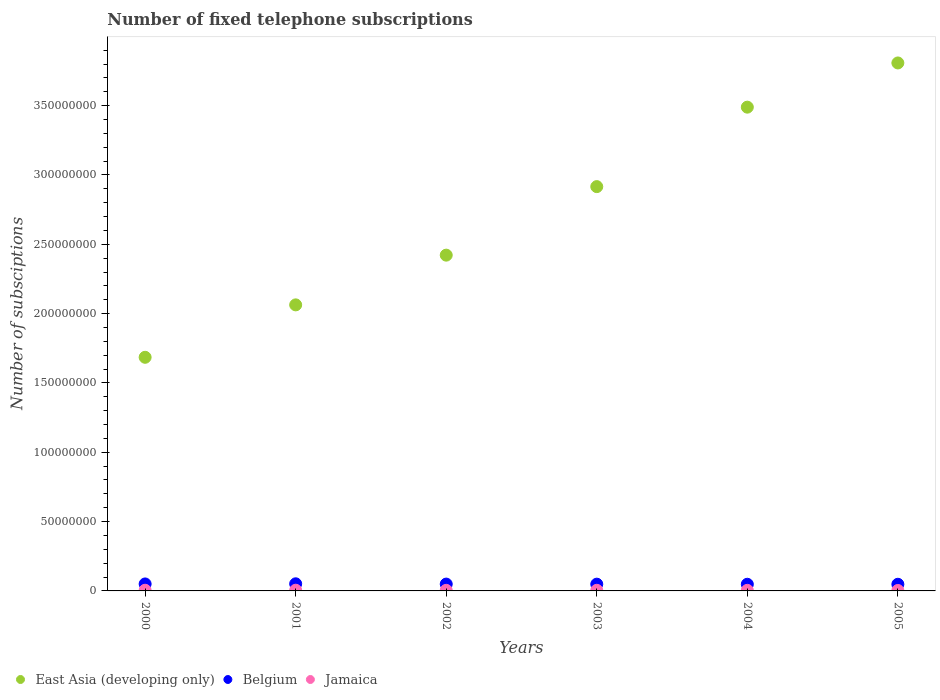Is the number of dotlines equal to the number of legend labels?
Make the answer very short. Yes. What is the number of fixed telephone subscriptions in East Asia (developing only) in 2001?
Provide a short and direct response. 2.06e+08. Across all years, what is the maximum number of fixed telephone subscriptions in Jamaica?
Your response must be concise. 5.11e+05. Across all years, what is the minimum number of fixed telephone subscriptions in Jamaica?
Provide a succinct answer. 3.19e+05. What is the total number of fixed telephone subscriptions in East Asia (developing only) in the graph?
Offer a very short reply. 1.64e+09. What is the difference between the number of fixed telephone subscriptions in Belgium in 2001 and that in 2005?
Offer a very short reply. 3.37e+05. What is the difference between the number of fixed telephone subscriptions in East Asia (developing only) in 2003 and the number of fixed telephone subscriptions in Belgium in 2001?
Provide a succinct answer. 2.86e+08. What is the average number of fixed telephone subscriptions in East Asia (developing only) per year?
Your response must be concise. 2.73e+08. In the year 2002, what is the difference between the number of fixed telephone subscriptions in East Asia (developing only) and number of fixed telephone subscriptions in Belgium?
Provide a succinct answer. 2.37e+08. In how many years, is the number of fixed telephone subscriptions in Belgium greater than 110000000?
Provide a succinct answer. 0. What is the ratio of the number of fixed telephone subscriptions in East Asia (developing only) in 2001 to that in 2005?
Your answer should be compact. 0.54. What is the difference between the highest and the second highest number of fixed telephone subscriptions in Jamaica?
Your response must be concise. 1.78e+04. What is the difference between the highest and the lowest number of fixed telephone subscriptions in Jamaica?
Keep it short and to the point. 1.92e+05. In how many years, is the number of fixed telephone subscriptions in Jamaica greater than the average number of fixed telephone subscriptions in Jamaica taken over all years?
Ensure brevity in your answer.  3. How many dotlines are there?
Give a very brief answer. 3. How many years are there in the graph?
Your response must be concise. 6. Are the values on the major ticks of Y-axis written in scientific E-notation?
Offer a very short reply. No. Does the graph contain grids?
Provide a succinct answer. No. Where does the legend appear in the graph?
Offer a terse response. Bottom left. What is the title of the graph?
Your answer should be very brief. Number of fixed telephone subscriptions. Does "West Bank and Gaza" appear as one of the legend labels in the graph?
Keep it short and to the point. No. What is the label or title of the Y-axis?
Ensure brevity in your answer.  Number of subsciptions. What is the Number of subsciptions of East Asia (developing only) in 2000?
Offer a terse response. 1.68e+08. What is the Number of subsciptions of Belgium in 2000?
Offer a very short reply. 5.04e+06. What is the Number of subsciptions of Jamaica in 2000?
Keep it short and to the point. 4.94e+05. What is the Number of subsciptions in East Asia (developing only) in 2001?
Offer a very short reply. 2.06e+08. What is the Number of subsciptions in Belgium in 2001?
Your answer should be compact. 5.13e+06. What is the Number of subsciptions in Jamaica in 2001?
Your answer should be very brief. 5.11e+05. What is the Number of subsciptions in East Asia (developing only) in 2002?
Offer a very short reply. 2.42e+08. What is the Number of subsciptions of Belgium in 2002?
Give a very brief answer. 4.93e+06. What is the Number of subsciptions in Jamaica in 2002?
Provide a short and direct response. 4.35e+05. What is the Number of subsciptions of East Asia (developing only) in 2003?
Ensure brevity in your answer.  2.92e+08. What is the Number of subsciptions of Belgium in 2003?
Keep it short and to the point. 4.88e+06. What is the Number of subsciptions of Jamaica in 2003?
Your answer should be compact. 4.59e+05. What is the Number of subsciptions in East Asia (developing only) in 2004?
Provide a short and direct response. 3.49e+08. What is the Number of subsciptions in Belgium in 2004?
Your answer should be compact. 4.80e+06. What is the Number of subsciptions of Jamaica in 2004?
Make the answer very short. 4.23e+05. What is the Number of subsciptions of East Asia (developing only) in 2005?
Offer a very short reply. 3.81e+08. What is the Number of subsciptions in Belgium in 2005?
Offer a terse response. 4.79e+06. What is the Number of subsciptions of Jamaica in 2005?
Your answer should be very brief. 3.19e+05. Across all years, what is the maximum Number of subsciptions of East Asia (developing only)?
Provide a short and direct response. 3.81e+08. Across all years, what is the maximum Number of subsciptions of Belgium?
Your answer should be compact. 5.13e+06. Across all years, what is the maximum Number of subsciptions of Jamaica?
Ensure brevity in your answer.  5.11e+05. Across all years, what is the minimum Number of subsciptions in East Asia (developing only)?
Your response must be concise. 1.68e+08. Across all years, what is the minimum Number of subsciptions of Belgium?
Your response must be concise. 4.79e+06. Across all years, what is the minimum Number of subsciptions in Jamaica?
Your answer should be very brief. 3.19e+05. What is the total Number of subsciptions of East Asia (developing only) in the graph?
Give a very brief answer. 1.64e+09. What is the total Number of subsciptions of Belgium in the graph?
Your answer should be compact. 2.96e+07. What is the total Number of subsciptions of Jamaica in the graph?
Your answer should be very brief. 2.64e+06. What is the difference between the Number of subsciptions of East Asia (developing only) in 2000 and that in 2001?
Offer a terse response. -3.78e+07. What is the difference between the Number of subsciptions in Belgium in 2000 and that in 2001?
Provide a short and direct response. -9.53e+04. What is the difference between the Number of subsciptions in Jamaica in 2000 and that in 2001?
Offer a very short reply. -1.78e+04. What is the difference between the Number of subsciptions in East Asia (developing only) in 2000 and that in 2002?
Your answer should be compact. -7.37e+07. What is the difference between the Number of subsciptions in Belgium in 2000 and that in 2002?
Make the answer very short. 1.05e+05. What is the difference between the Number of subsciptions of Jamaica in 2000 and that in 2002?
Your response must be concise. 5.88e+04. What is the difference between the Number of subsciptions of East Asia (developing only) in 2000 and that in 2003?
Your response must be concise. -1.23e+08. What is the difference between the Number of subsciptions of Belgium in 2000 and that in 2003?
Your answer should be compact. 1.61e+05. What is the difference between the Number of subsciptions of Jamaica in 2000 and that in 2003?
Provide a succinct answer. 3.48e+04. What is the difference between the Number of subsciptions in East Asia (developing only) in 2000 and that in 2004?
Keep it short and to the point. -1.80e+08. What is the difference between the Number of subsciptions in Belgium in 2000 and that in 2004?
Ensure brevity in your answer.  2.35e+05. What is the difference between the Number of subsciptions in Jamaica in 2000 and that in 2004?
Your answer should be compact. 7.05e+04. What is the difference between the Number of subsciptions in East Asia (developing only) in 2000 and that in 2005?
Offer a very short reply. -2.12e+08. What is the difference between the Number of subsciptions of Belgium in 2000 and that in 2005?
Ensure brevity in your answer.  2.42e+05. What is the difference between the Number of subsciptions in Jamaica in 2000 and that in 2005?
Your answer should be very brief. 1.75e+05. What is the difference between the Number of subsciptions of East Asia (developing only) in 2001 and that in 2002?
Your answer should be very brief. -3.59e+07. What is the difference between the Number of subsciptions in Belgium in 2001 and that in 2002?
Give a very brief answer. 2.00e+05. What is the difference between the Number of subsciptions of Jamaica in 2001 and that in 2002?
Make the answer very short. 7.65e+04. What is the difference between the Number of subsciptions of East Asia (developing only) in 2001 and that in 2003?
Your answer should be very brief. -8.53e+07. What is the difference between the Number of subsciptions in Belgium in 2001 and that in 2003?
Your answer should be compact. 2.57e+05. What is the difference between the Number of subsciptions in Jamaica in 2001 and that in 2003?
Provide a succinct answer. 5.26e+04. What is the difference between the Number of subsciptions of East Asia (developing only) in 2001 and that in 2004?
Give a very brief answer. -1.43e+08. What is the difference between the Number of subsciptions of Belgium in 2001 and that in 2004?
Your response must be concise. 3.31e+05. What is the difference between the Number of subsciptions of Jamaica in 2001 and that in 2004?
Your answer should be compact. 8.83e+04. What is the difference between the Number of subsciptions of East Asia (developing only) in 2001 and that in 2005?
Your answer should be compact. -1.74e+08. What is the difference between the Number of subsciptions in Belgium in 2001 and that in 2005?
Your answer should be compact. 3.37e+05. What is the difference between the Number of subsciptions in Jamaica in 2001 and that in 2005?
Make the answer very short. 1.92e+05. What is the difference between the Number of subsciptions in East Asia (developing only) in 2002 and that in 2003?
Give a very brief answer. -4.94e+07. What is the difference between the Number of subsciptions in Belgium in 2002 and that in 2003?
Ensure brevity in your answer.  5.66e+04. What is the difference between the Number of subsciptions of Jamaica in 2002 and that in 2003?
Keep it short and to the point. -2.39e+04. What is the difference between the Number of subsciptions in East Asia (developing only) in 2002 and that in 2004?
Offer a very short reply. -1.07e+08. What is the difference between the Number of subsciptions of Belgium in 2002 and that in 2004?
Your response must be concise. 1.31e+05. What is the difference between the Number of subsciptions of Jamaica in 2002 and that in 2004?
Provide a succinct answer. 1.18e+04. What is the difference between the Number of subsciptions in East Asia (developing only) in 2002 and that in 2005?
Provide a short and direct response. -1.39e+08. What is the difference between the Number of subsciptions of Belgium in 2002 and that in 2005?
Ensure brevity in your answer.  1.37e+05. What is the difference between the Number of subsciptions in Jamaica in 2002 and that in 2005?
Offer a very short reply. 1.16e+05. What is the difference between the Number of subsciptions in East Asia (developing only) in 2003 and that in 2004?
Your answer should be very brief. -5.73e+07. What is the difference between the Number of subsciptions of Belgium in 2003 and that in 2004?
Offer a terse response. 7.40e+04. What is the difference between the Number of subsciptions of Jamaica in 2003 and that in 2004?
Your answer should be compact. 3.57e+04. What is the difference between the Number of subsciptions in East Asia (developing only) in 2003 and that in 2005?
Make the answer very short. -8.92e+07. What is the difference between the Number of subsciptions in Belgium in 2003 and that in 2005?
Offer a terse response. 8.04e+04. What is the difference between the Number of subsciptions of Jamaica in 2003 and that in 2005?
Offer a terse response. 1.40e+05. What is the difference between the Number of subsciptions of East Asia (developing only) in 2004 and that in 2005?
Provide a succinct answer. -3.19e+07. What is the difference between the Number of subsciptions of Belgium in 2004 and that in 2005?
Ensure brevity in your answer.  6417. What is the difference between the Number of subsciptions of Jamaica in 2004 and that in 2005?
Provide a succinct answer. 1.04e+05. What is the difference between the Number of subsciptions of East Asia (developing only) in 2000 and the Number of subsciptions of Belgium in 2001?
Ensure brevity in your answer.  1.63e+08. What is the difference between the Number of subsciptions in East Asia (developing only) in 2000 and the Number of subsciptions in Jamaica in 2001?
Give a very brief answer. 1.68e+08. What is the difference between the Number of subsciptions of Belgium in 2000 and the Number of subsciptions of Jamaica in 2001?
Ensure brevity in your answer.  4.53e+06. What is the difference between the Number of subsciptions of East Asia (developing only) in 2000 and the Number of subsciptions of Belgium in 2002?
Your response must be concise. 1.64e+08. What is the difference between the Number of subsciptions in East Asia (developing only) in 2000 and the Number of subsciptions in Jamaica in 2002?
Give a very brief answer. 1.68e+08. What is the difference between the Number of subsciptions in Belgium in 2000 and the Number of subsciptions in Jamaica in 2002?
Provide a succinct answer. 4.60e+06. What is the difference between the Number of subsciptions of East Asia (developing only) in 2000 and the Number of subsciptions of Belgium in 2003?
Provide a short and direct response. 1.64e+08. What is the difference between the Number of subsciptions in East Asia (developing only) in 2000 and the Number of subsciptions in Jamaica in 2003?
Offer a very short reply. 1.68e+08. What is the difference between the Number of subsciptions in Belgium in 2000 and the Number of subsciptions in Jamaica in 2003?
Give a very brief answer. 4.58e+06. What is the difference between the Number of subsciptions in East Asia (developing only) in 2000 and the Number of subsciptions in Belgium in 2004?
Offer a very short reply. 1.64e+08. What is the difference between the Number of subsciptions in East Asia (developing only) in 2000 and the Number of subsciptions in Jamaica in 2004?
Ensure brevity in your answer.  1.68e+08. What is the difference between the Number of subsciptions of Belgium in 2000 and the Number of subsciptions of Jamaica in 2004?
Give a very brief answer. 4.61e+06. What is the difference between the Number of subsciptions in East Asia (developing only) in 2000 and the Number of subsciptions in Belgium in 2005?
Ensure brevity in your answer.  1.64e+08. What is the difference between the Number of subsciptions of East Asia (developing only) in 2000 and the Number of subsciptions of Jamaica in 2005?
Give a very brief answer. 1.68e+08. What is the difference between the Number of subsciptions of Belgium in 2000 and the Number of subsciptions of Jamaica in 2005?
Provide a short and direct response. 4.72e+06. What is the difference between the Number of subsciptions of East Asia (developing only) in 2001 and the Number of subsciptions of Belgium in 2002?
Your answer should be compact. 2.01e+08. What is the difference between the Number of subsciptions in East Asia (developing only) in 2001 and the Number of subsciptions in Jamaica in 2002?
Make the answer very short. 2.06e+08. What is the difference between the Number of subsciptions of Belgium in 2001 and the Number of subsciptions of Jamaica in 2002?
Give a very brief answer. 4.70e+06. What is the difference between the Number of subsciptions of East Asia (developing only) in 2001 and the Number of subsciptions of Belgium in 2003?
Provide a short and direct response. 2.01e+08. What is the difference between the Number of subsciptions of East Asia (developing only) in 2001 and the Number of subsciptions of Jamaica in 2003?
Your answer should be compact. 2.06e+08. What is the difference between the Number of subsciptions in Belgium in 2001 and the Number of subsciptions in Jamaica in 2003?
Your answer should be compact. 4.67e+06. What is the difference between the Number of subsciptions in East Asia (developing only) in 2001 and the Number of subsciptions in Belgium in 2004?
Your response must be concise. 2.01e+08. What is the difference between the Number of subsciptions in East Asia (developing only) in 2001 and the Number of subsciptions in Jamaica in 2004?
Give a very brief answer. 2.06e+08. What is the difference between the Number of subsciptions in Belgium in 2001 and the Number of subsciptions in Jamaica in 2004?
Ensure brevity in your answer.  4.71e+06. What is the difference between the Number of subsciptions of East Asia (developing only) in 2001 and the Number of subsciptions of Belgium in 2005?
Provide a succinct answer. 2.02e+08. What is the difference between the Number of subsciptions in East Asia (developing only) in 2001 and the Number of subsciptions in Jamaica in 2005?
Your response must be concise. 2.06e+08. What is the difference between the Number of subsciptions of Belgium in 2001 and the Number of subsciptions of Jamaica in 2005?
Provide a succinct answer. 4.81e+06. What is the difference between the Number of subsciptions in East Asia (developing only) in 2002 and the Number of subsciptions in Belgium in 2003?
Make the answer very short. 2.37e+08. What is the difference between the Number of subsciptions of East Asia (developing only) in 2002 and the Number of subsciptions of Jamaica in 2003?
Make the answer very short. 2.42e+08. What is the difference between the Number of subsciptions in Belgium in 2002 and the Number of subsciptions in Jamaica in 2003?
Make the answer very short. 4.47e+06. What is the difference between the Number of subsciptions in East Asia (developing only) in 2002 and the Number of subsciptions in Belgium in 2004?
Give a very brief answer. 2.37e+08. What is the difference between the Number of subsciptions in East Asia (developing only) in 2002 and the Number of subsciptions in Jamaica in 2004?
Provide a short and direct response. 2.42e+08. What is the difference between the Number of subsciptions of Belgium in 2002 and the Number of subsciptions of Jamaica in 2004?
Offer a very short reply. 4.51e+06. What is the difference between the Number of subsciptions of East Asia (developing only) in 2002 and the Number of subsciptions of Belgium in 2005?
Offer a terse response. 2.37e+08. What is the difference between the Number of subsciptions in East Asia (developing only) in 2002 and the Number of subsciptions in Jamaica in 2005?
Offer a terse response. 2.42e+08. What is the difference between the Number of subsciptions in Belgium in 2002 and the Number of subsciptions in Jamaica in 2005?
Provide a succinct answer. 4.61e+06. What is the difference between the Number of subsciptions in East Asia (developing only) in 2003 and the Number of subsciptions in Belgium in 2004?
Your response must be concise. 2.87e+08. What is the difference between the Number of subsciptions in East Asia (developing only) in 2003 and the Number of subsciptions in Jamaica in 2004?
Your answer should be very brief. 2.91e+08. What is the difference between the Number of subsciptions of Belgium in 2003 and the Number of subsciptions of Jamaica in 2004?
Your answer should be very brief. 4.45e+06. What is the difference between the Number of subsciptions in East Asia (developing only) in 2003 and the Number of subsciptions in Belgium in 2005?
Give a very brief answer. 2.87e+08. What is the difference between the Number of subsciptions of East Asia (developing only) in 2003 and the Number of subsciptions of Jamaica in 2005?
Provide a succinct answer. 2.91e+08. What is the difference between the Number of subsciptions in Belgium in 2003 and the Number of subsciptions in Jamaica in 2005?
Keep it short and to the point. 4.56e+06. What is the difference between the Number of subsciptions in East Asia (developing only) in 2004 and the Number of subsciptions in Belgium in 2005?
Give a very brief answer. 3.44e+08. What is the difference between the Number of subsciptions of East Asia (developing only) in 2004 and the Number of subsciptions of Jamaica in 2005?
Keep it short and to the point. 3.49e+08. What is the difference between the Number of subsciptions of Belgium in 2004 and the Number of subsciptions of Jamaica in 2005?
Your response must be concise. 4.48e+06. What is the average Number of subsciptions of East Asia (developing only) per year?
Your answer should be compact. 2.73e+08. What is the average Number of subsciptions of Belgium per year?
Offer a terse response. 4.93e+06. What is the average Number of subsciptions of Jamaica per year?
Provide a short and direct response. 4.40e+05. In the year 2000, what is the difference between the Number of subsciptions in East Asia (developing only) and Number of subsciptions in Belgium?
Provide a succinct answer. 1.63e+08. In the year 2000, what is the difference between the Number of subsciptions of East Asia (developing only) and Number of subsciptions of Jamaica?
Provide a succinct answer. 1.68e+08. In the year 2000, what is the difference between the Number of subsciptions in Belgium and Number of subsciptions in Jamaica?
Give a very brief answer. 4.54e+06. In the year 2001, what is the difference between the Number of subsciptions in East Asia (developing only) and Number of subsciptions in Belgium?
Provide a short and direct response. 2.01e+08. In the year 2001, what is the difference between the Number of subsciptions of East Asia (developing only) and Number of subsciptions of Jamaica?
Keep it short and to the point. 2.06e+08. In the year 2001, what is the difference between the Number of subsciptions in Belgium and Number of subsciptions in Jamaica?
Offer a very short reply. 4.62e+06. In the year 2002, what is the difference between the Number of subsciptions in East Asia (developing only) and Number of subsciptions in Belgium?
Give a very brief answer. 2.37e+08. In the year 2002, what is the difference between the Number of subsciptions in East Asia (developing only) and Number of subsciptions in Jamaica?
Make the answer very short. 2.42e+08. In the year 2002, what is the difference between the Number of subsciptions of Belgium and Number of subsciptions of Jamaica?
Provide a short and direct response. 4.50e+06. In the year 2003, what is the difference between the Number of subsciptions of East Asia (developing only) and Number of subsciptions of Belgium?
Provide a short and direct response. 2.87e+08. In the year 2003, what is the difference between the Number of subsciptions of East Asia (developing only) and Number of subsciptions of Jamaica?
Keep it short and to the point. 2.91e+08. In the year 2003, what is the difference between the Number of subsciptions in Belgium and Number of subsciptions in Jamaica?
Your answer should be very brief. 4.42e+06. In the year 2004, what is the difference between the Number of subsciptions in East Asia (developing only) and Number of subsciptions in Belgium?
Ensure brevity in your answer.  3.44e+08. In the year 2004, what is the difference between the Number of subsciptions in East Asia (developing only) and Number of subsciptions in Jamaica?
Your answer should be very brief. 3.48e+08. In the year 2004, what is the difference between the Number of subsciptions in Belgium and Number of subsciptions in Jamaica?
Give a very brief answer. 4.38e+06. In the year 2005, what is the difference between the Number of subsciptions of East Asia (developing only) and Number of subsciptions of Belgium?
Provide a succinct answer. 3.76e+08. In the year 2005, what is the difference between the Number of subsciptions in East Asia (developing only) and Number of subsciptions in Jamaica?
Your answer should be very brief. 3.80e+08. In the year 2005, what is the difference between the Number of subsciptions in Belgium and Number of subsciptions in Jamaica?
Give a very brief answer. 4.48e+06. What is the ratio of the Number of subsciptions in East Asia (developing only) in 2000 to that in 2001?
Offer a very short reply. 0.82. What is the ratio of the Number of subsciptions in Belgium in 2000 to that in 2001?
Your response must be concise. 0.98. What is the ratio of the Number of subsciptions in Jamaica in 2000 to that in 2001?
Provide a short and direct response. 0.97. What is the ratio of the Number of subsciptions in East Asia (developing only) in 2000 to that in 2002?
Your response must be concise. 0.7. What is the ratio of the Number of subsciptions of Belgium in 2000 to that in 2002?
Keep it short and to the point. 1.02. What is the ratio of the Number of subsciptions in Jamaica in 2000 to that in 2002?
Give a very brief answer. 1.14. What is the ratio of the Number of subsciptions in East Asia (developing only) in 2000 to that in 2003?
Your answer should be compact. 0.58. What is the ratio of the Number of subsciptions in Belgium in 2000 to that in 2003?
Provide a short and direct response. 1.03. What is the ratio of the Number of subsciptions of Jamaica in 2000 to that in 2003?
Make the answer very short. 1.08. What is the ratio of the Number of subsciptions in East Asia (developing only) in 2000 to that in 2004?
Keep it short and to the point. 0.48. What is the ratio of the Number of subsciptions of Belgium in 2000 to that in 2004?
Ensure brevity in your answer.  1.05. What is the ratio of the Number of subsciptions in East Asia (developing only) in 2000 to that in 2005?
Offer a very short reply. 0.44. What is the ratio of the Number of subsciptions of Belgium in 2000 to that in 2005?
Provide a succinct answer. 1.05. What is the ratio of the Number of subsciptions in Jamaica in 2000 to that in 2005?
Your answer should be compact. 1.55. What is the ratio of the Number of subsciptions in East Asia (developing only) in 2001 to that in 2002?
Offer a terse response. 0.85. What is the ratio of the Number of subsciptions in Belgium in 2001 to that in 2002?
Offer a very short reply. 1.04. What is the ratio of the Number of subsciptions of Jamaica in 2001 to that in 2002?
Offer a terse response. 1.18. What is the ratio of the Number of subsciptions of East Asia (developing only) in 2001 to that in 2003?
Make the answer very short. 0.71. What is the ratio of the Number of subsciptions in Belgium in 2001 to that in 2003?
Offer a terse response. 1.05. What is the ratio of the Number of subsciptions in Jamaica in 2001 to that in 2003?
Your response must be concise. 1.11. What is the ratio of the Number of subsciptions of East Asia (developing only) in 2001 to that in 2004?
Offer a terse response. 0.59. What is the ratio of the Number of subsciptions in Belgium in 2001 to that in 2004?
Ensure brevity in your answer.  1.07. What is the ratio of the Number of subsciptions in Jamaica in 2001 to that in 2004?
Ensure brevity in your answer.  1.21. What is the ratio of the Number of subsciptions in East Asia (developing only) in 2001 to that in 2005?
Give a very brief answer. 0.54. What is the ratio of the Number of subsciptions of Belgium in 2001 to that in 2005?
Your answer should be very brief. 1.07. What is the ratio of the Number of subsciptions in Jamaica in 2001 to that in 2005?
Your answer should be very brief. 1.6. What is the ratio of the Number of subsciptions in East Asia (developing only) in 2002 to that in 2003?
Your answer should be very brief. 0.83. What is the ratio of the Number of subsciptions in Belgium in 2002 to that in 2003?
Give a very brief answer. 1.01. What is the ratio of the Number of subsciptions in Jamaica in 2002 to that in 2003?
Your answer should be compact. 0.95. What is the ratio of the Number of subsciptions of East Asia (developing only) in 2002 to that in 2004?
Provide a short and direct response. 0.69. What is the ratio of the Number of subsciptions in Belgium in 2002 to that in 2004?
Your answer should be compact. 1.03. What is the ratio of the Number of subsciptions of Jamaica in 2002 to that in 2004?
Give a very brief answer. 1.03. What is the ratio of the Number of subsciptions in East Asia (developing only) in 2002 to that in 2005?
Offer a very short reply. 0.64. What is the ratio of the Number of subsciptions of Belgium in 2002 to that in 2005?
Provide a succinct answer. 1.03. What is the ratio of the Number of subsciptions in Jamaica in 2002 to that in 2005?
Your response must be concise. 1.36. What is the ratio of the Number of subsciptions of East Asia (developing only) in 2003 to that in 2004?
Make the answer very short. 0.84. What is the ratio of the Number of subsciptions of Belgium in 2003 to that in 2004?
Your answer should be compact. 1.02. What is the ratio of the Number of subsciptions in Jamaica in 2003 to that in 2004?
Provide a short and direct response. 1.08. What is the ratio of the Number of subsciptions of East Asia (developing only) in 2003 to that in 2005?
Give a very brief answer. 0.77. What is the ratio of the Number of subsciptions in Belgium in 2003 to that in 2005?
Your response must be concise. 1.02. What is the ratio of the Number of subsciptions of Jamaica in 2003 to that in 2005?
Offer a terse response. 1.44. What is the ratio of the Number of subsciptions in East Asia (developing only) in 2004 to that in 2005?
Your response must be concise. 0.92. What is the ratio of the Number of subsciptions in Belgium in 2004 to that in 2005?
Give a very brief answer. 1. What is the ratio of the Number of subsciptions of Jamaica in 2004 to that in 2005?
Make the answer very short. 1.33. What is the difference between the highest and the second highest Number of subsciptions of East Asia (developing only)?
Your response must be concise. 3.19e+07. What is the difference between the highest and the second highest Number of subsciptions in Belgium?
Give a very brief answer. 9.53e+04. What is the difference between the highest and the second highest Number of subsciptions of Jamaica?
Give a very brief answer. 1.78e+04. What is the difference between the highest and the lowest Number of subsciptions of East Asia (developing only)?
Keep it short and to the point. 2.12e+08. What is the difference between the highest and the lowest Number of subsciptions in Belgium?
Your response must be concise. 3.37e+05. What is the difference between the highest and the lowest Number of subsciptions of Jamaica?
Your answer should be very brief. 1.92e+05. 